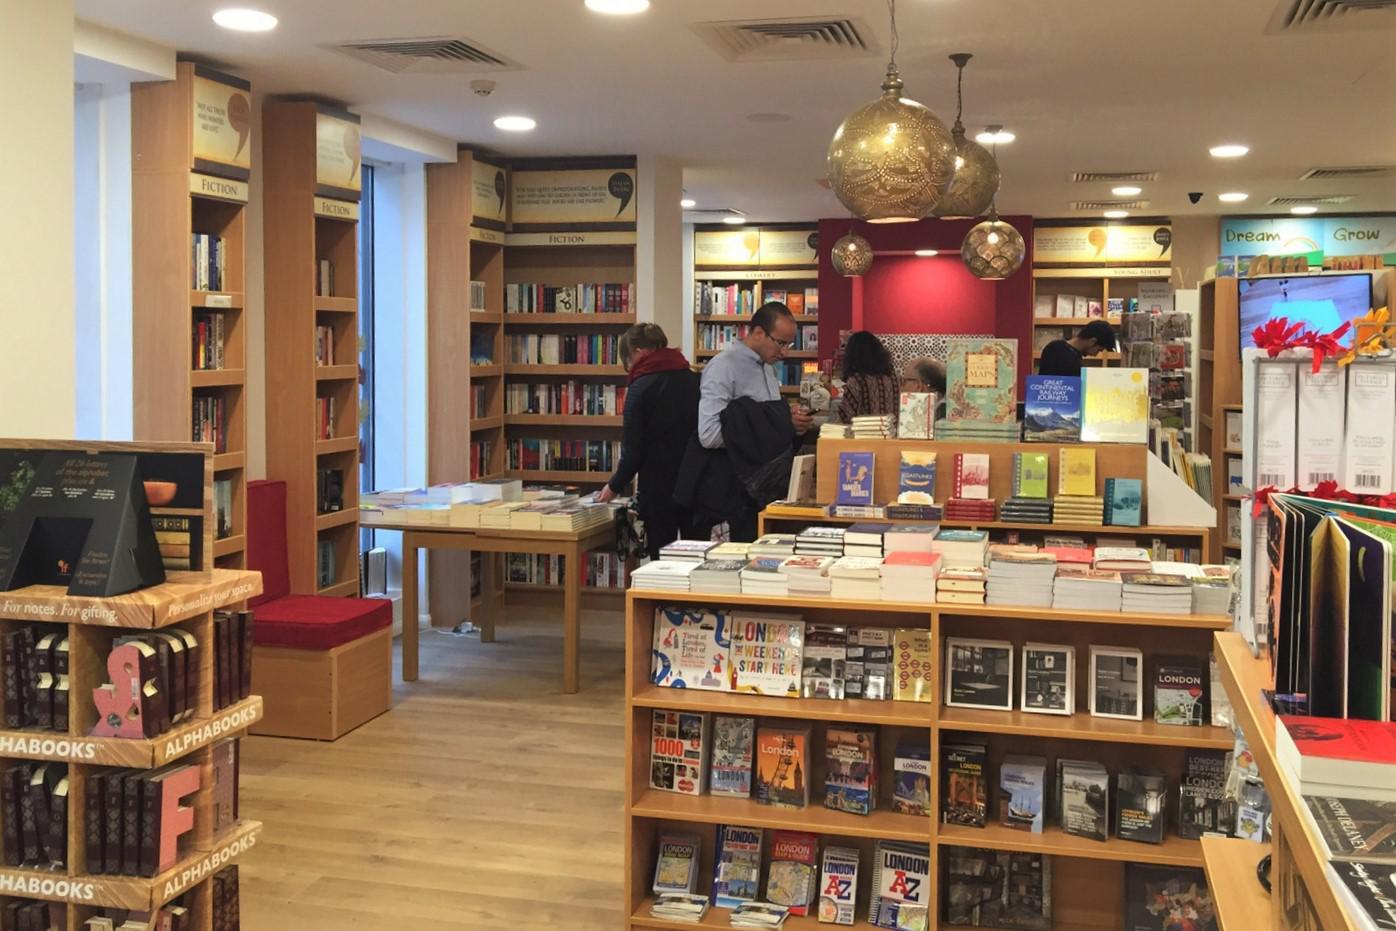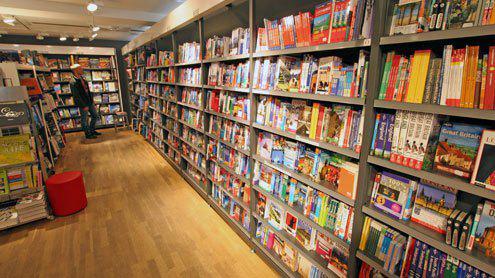The first image is the image on the left, the second image is the image on the right. For the images shown, is this caption "An image shows a shop interior which includes displays of apparel." true? Answer yes or no. No. 